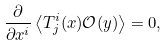<formula> <loc_0><loc_0><loc_500><loc_500>\frac { \partial } { \partial x ^ { i } } \left \langle T ^ { i } _ { j } ( x ) \mathcal { O } ( y ) \right \rangle = 0 ,</formula> 